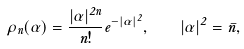Convert formula to latex. <formula><loc_0><loc_0><loc_500><loc_500>\rho _ { n } ( \alpha ) = \frac { | \alpha | ^ { 2 n } } { n ! } e ^ { - | \alpha | ^ { 2 } } , \quad | \alpha | ^ { 2 } = \bar { n } ,</formula> 